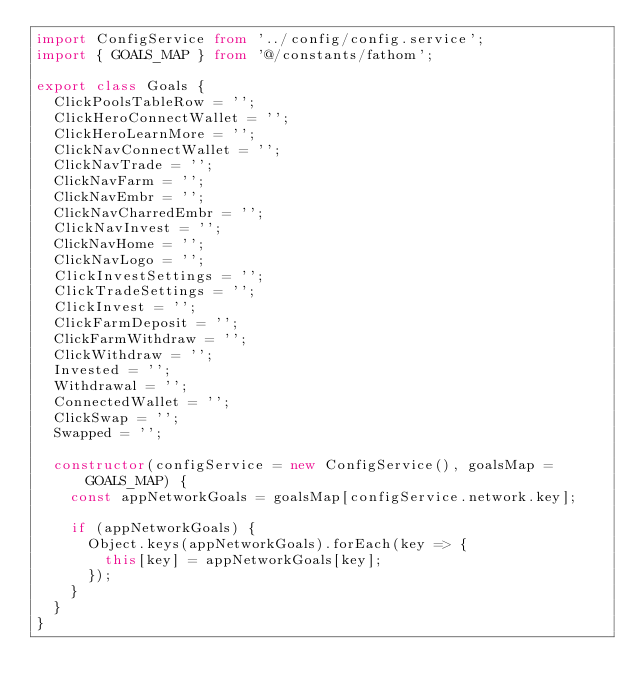<code> <loc_0><loc_0><loc_500><loc_500><_TypeScript_>import ConfigService from '../config/config.service';
import { GOALS_MAP } from '@/constants/fathom';

export class Goals {
  ClickPoolsTableRow = '';
  ClickHeroConnectWallet = '';
  ClickHeroLearnMore = '';
  ClickNavConnectWallet = '';
  ClickNavTrade = '';
  ClickNavFarm = '';
  ClickNavEmbr = '';
  ClickNavCharredEmbr = '';
  ClickNavInvest = '';
  ClickNavHome = '';
  ClickNavLogo = '';
  ClickInvestSettings = '';
  ClickTradeSettings = '';
  ClickInvest = '';
  ClickFarmDeposit = '';
  ClickFarmWithdraw = '';
  ClickWithdraw = '';
  Invested = '';
  Withdrawal = '';
  ConnectedWallet = '';
  ClickSwap = '';
  Swapped = '';

  constructor(configService = new ConfigService(), goalsMap = GOALS_MAP) {
    const appNetworkGoals = goalsMap[configService.network.key];

    if (appNetworkGoals) {
      Object.keys(appNetworkGoals).forEach(key => {
        this[key] = appNetworkGoals[key];
      });
    }
  }
}
</code> 